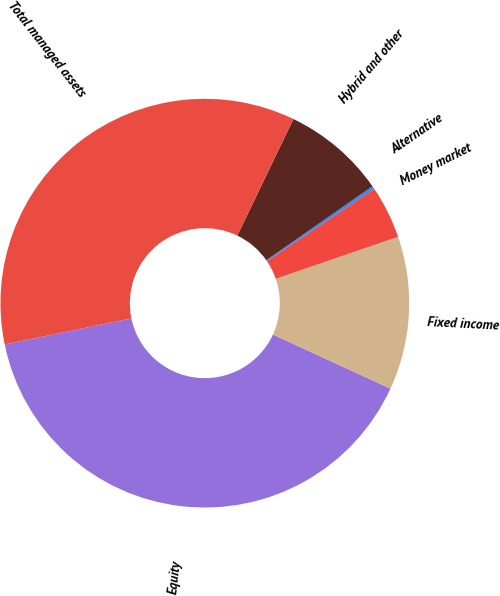Convert chart to OTSL. <chart><loc_0><loc_0><loc_500><loc_500><pie_chart><fcel>Equity<fcel>Fixed income<fcel>Money market<fcel>Alternative<fcel>Hybrid and other<fcel>Total managed assets<nl><fcel>39.89%<fcel>12.13%<fcel>4.2%<fcel>0.23%<fcel>8.17%<fcel>35.37%<nl></chart> 